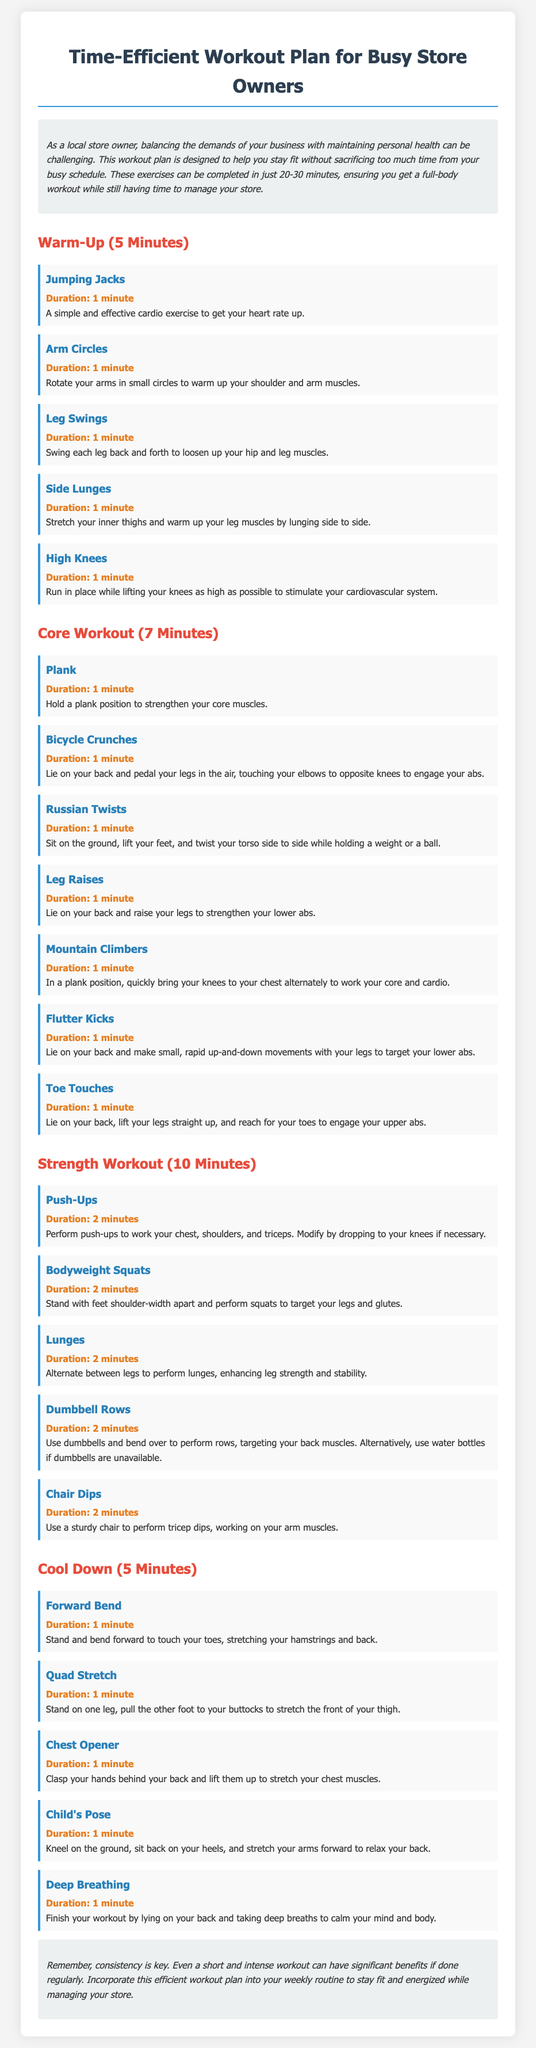What is the total duration of the workout plan? The workout plan includes a warm-up (5 minutes), core workout (7 minutes), strength workout (10 minutes), and cool down (5 minutes), totaling 27 minutes.
Answer: 27 minutes How many exercises are in the Core Workout section? The Core Workout section lists seven different exercises that target core strength.
Answer: 7 exercises What exercise comes first in the Warm-Up? The first exercise listed in the Warm-Up section is Jumping Jacks.
Answer: Jumping Jacks What is the duration of the Push-Ups exercise? The duration for Push-Ups in the Strength Workout section is 2 minutes, indicating a relatively short yet effective exercise.
Answer: 2 minutes What type of workout is recommended for 10 minutes? The document specifies that the Strength Workout section takes 10 minutes, focusing on building muscle strength.
Answer: Strength Workout What should you do to cool down according to the plan? The cool-down section includes exercises like Forward Bend, Quad Stretch, and others to help relax the muscles after a workout.
Answer: Cool down exercises How long should the Cool Down last? The document clearly states that the Cool Down should last for 5 minutes to effectively relax the body.
Answer: 5 minutes What is the concluding advice given in the document? The conclusion emphasizes that consistency in workouts is essential for maximizing benefits despite their short duration.
Answer: Consistency is key 